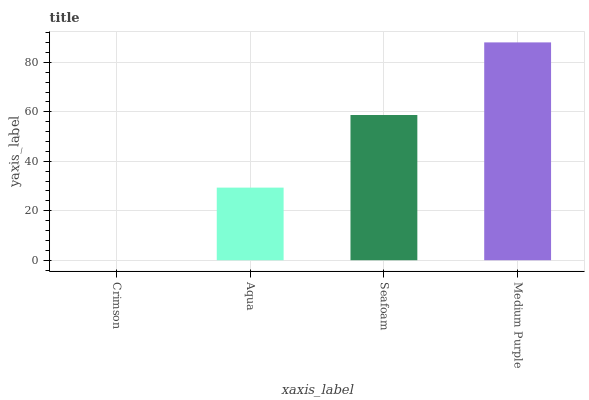Is Crimson the minimum?
Answer yes or no. Yes. Is Medium Purple the maximum?
Answer yes or no. Yes. Is Aqua the minimum?
Answer yes or no. No. Is Aqua the maximum?
Answer yes or no. No. Is Aqua greater than Crimson?
Answer yes or no. Yes. Is Crimson less than Aqua?
Answer yes or no. Yes. Is Crimson greater than Aqua?
Answer yes or no. No. Is Aqua less than Crimson?
Answer yes or no. No. Is Seafoam the high median?
Answer yes or no. Yes. Is Aqua the low median?
Answer yes or no. Yes. Is Crimson the high median?
Answer yes or no. No. Is Seafoam the low median?
Answer yes or no. No. 